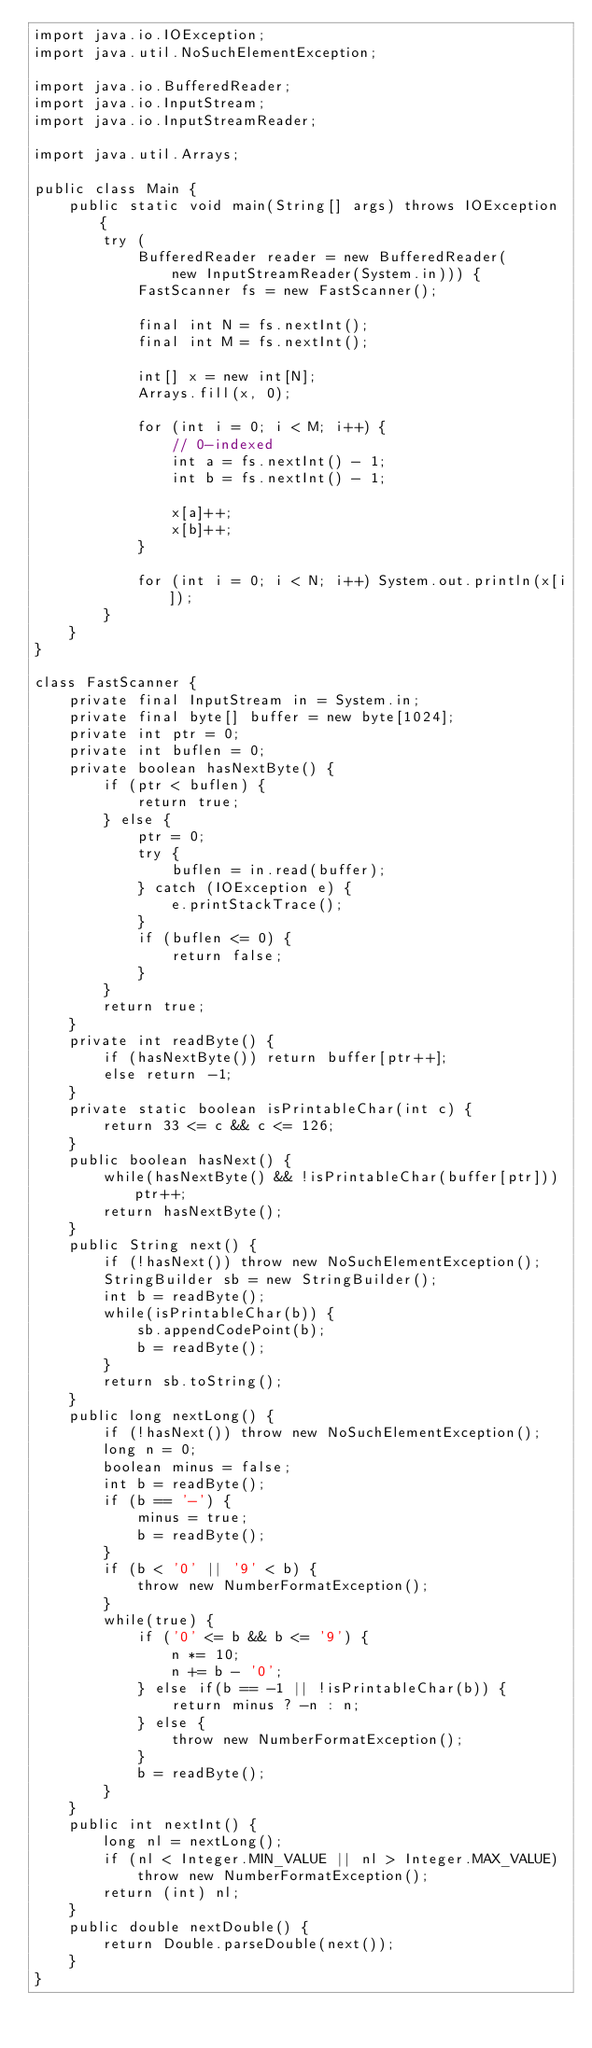<code> <loc_0><loc_0><loc_500><loc_500><_Java_>import java.io.IOException;
import java.util.NoSuchElementException;

import java.io.BufferedReader;
import java.io.InputStream;
import java.io.InputStreamReader;

import java.util.Arrays;

public class Main {
    public static void main(String[] args) throws IOException {
        try (
            BufferedReader reader = new BufferedReader(
                new InputStreamReader(System.in))) {
            FastScanner fs = new FastScanner();

            final int N = fs.nextInt();
            final int M = fs.nextInt();

            int[] x = new int[N];
            Arrays.fill(x, 0);

            for (int i = 0; i < M; i++) {
                // 0-indexed
                int a = fs.nextInt() - 1;
                int b = fs.nextInt() - 1;

                x[a]++;
                x[b]++;
            }

            for (int i = 0; i < N; i++) System.out.println(x[i]);
        }
    }
}

class FastScanner {
    private final InputStream in = System.in;
    private final byte[] buffer = new byte[1024];
    private int ptr = 0;
    private int buflen = 0;
    private boolean hasNextByte() {
        if (ptr < buflen) {
            return true;
        } else {
            ptr = 0;
            try {
                buflen = in.read(buffer);
            } catch (IOException e) {
                e.printStackTrace();
            }
            if (buflen <= 0) {
                return false;
            }
        }
        return true;
    }
    private int readByte() {
        if (hasNextByte()) return buffer[ptr++];
        else return -1;
    }
    private static boolean isPrintableChar(int c) {
        return 33 <= c && c <= 126;
    }
    public boolean hasNext() {
        while(hasNextByte() && !isPrintableChar(buffer[ptr])) ptr++;
        return hasNextByte();
    }
    public String next() {
        if (!hasNext()) throw new NoSuchElementException();
        StringBuilder sb = new StringBuilder();
        int b = readByte();
        while(isPrintableChar(b)) {
            sb.appendCodePoint(b);
            b = readByte();
        }
        return sb.toString();
    }
    public long nextLong() {
        if (!hasNext()) throw new NoSuchElementException();
        long n = 0;
        boolean minus = false;
        int b = readByte();
        if (b == '-') {
            minus = true;
            b = readByte();
        }
        if (b < '0' || '9' < b) {
            throw new NumberFormatException();
        }
        while(true) {
            if ('0' <= b && b <= '9') {
                n *= 10;
                n += b - '0';
            } else if(b == -1 || !isPrintableChar(b)) {
                return minus ? -n : n;
            } else {
                throw new NumberFormatException();
            }
            b = readByte();
        }
    }
    public int nextInt() {
        long nl = nextLong();
        if (nl < Integer.MIN_VALUE || nl > Integer.MAX_VALUE)
            throw new NumberFormatException();
        return (int) nl;
    }
    public double nextDouble() {
        return Double.parseDouble(next());
    }
}
</code> 